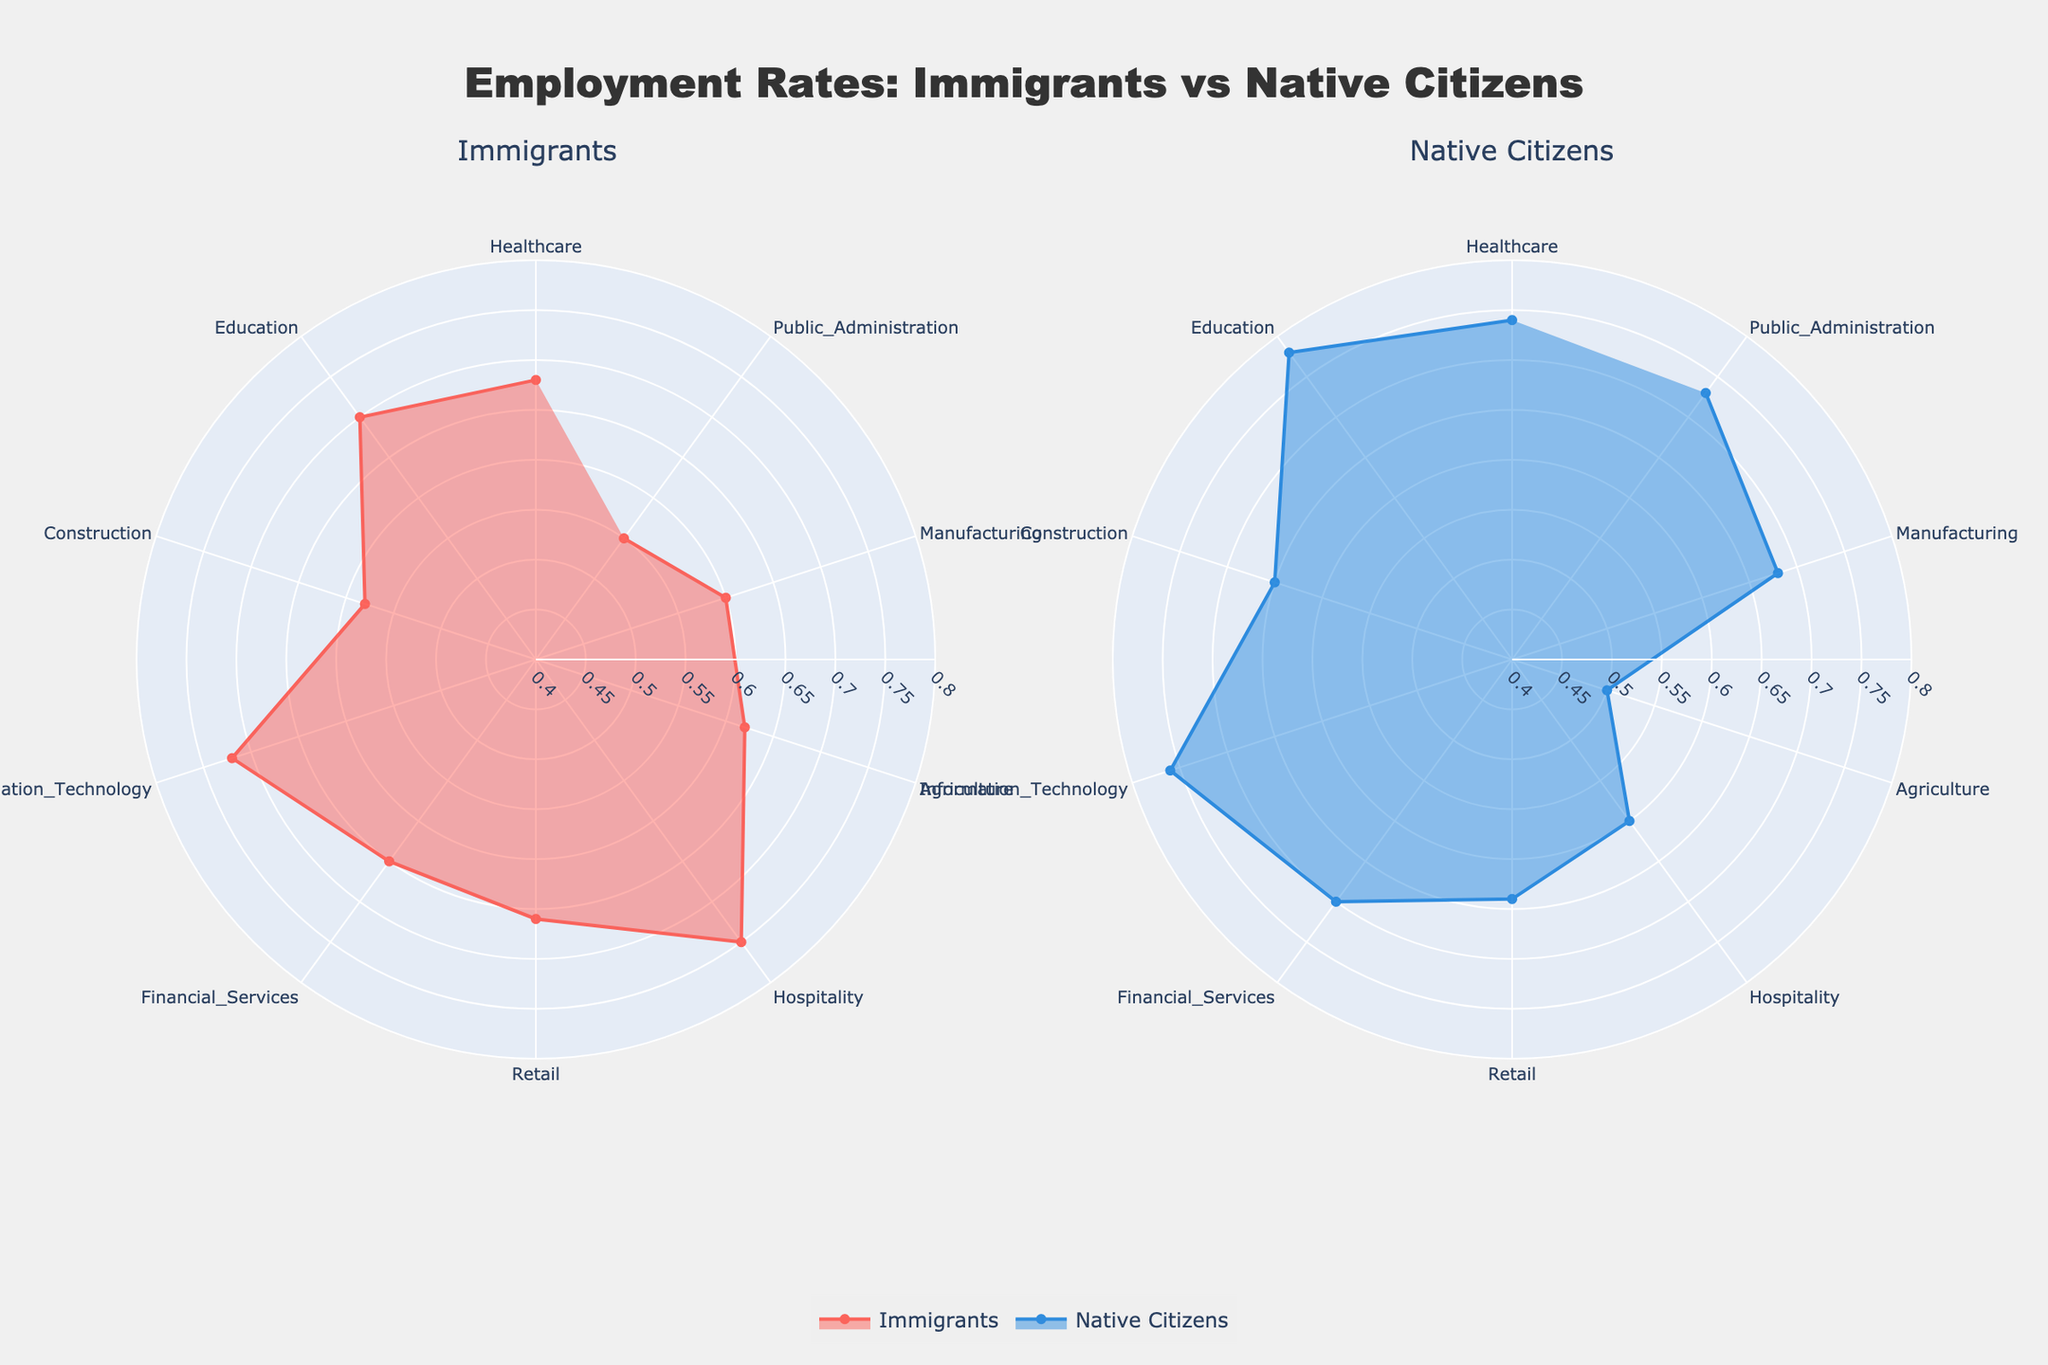What is the title of the figure? The title is displayed at the top center of the figure. It reads "Employment Rates: Immigrants vs Native Citizens" based on the code provided.
Answer: Employment Rates: Immigrants vs Native Citizens Which sector has the highest employment rate for immigrants? To find the highest employment rate, compare the values for immigrants in each sector. Hospitality has the highest rate with 0.75.
Answer: Hospitality In which sector is the employment rate for native citizens the highest? Review the employment rates for native citizens across sectors. Education has the highest rate of 0.78.
Answer: Education How does the employment rate for immigrants in the Information Technology sector compare to that for native citizens? The rate for immigrants in Information Technology is 0.72, while it is 0.76 for native citizens. Therefore, native citizens have a higher rate.
Answer: Native citizens have a higher rate Which sector shows the greatest difference in employment rates between immigrants and native citizens, and what is the difference? Calculate the differences in employment rates for each sector. Public Administration shows the greatest difference with native citizens at 0.73 and immigrants at 0.55, a difference of 0.18.
Answer: Public Administration, 0.18 What is the average employment rate for immigrants across all sectors? Sum the employment rates for immigrants and divide by the number of sectors: (0.68 + 0.70 + 0.58 + 0.72 + 0.65 + 0.66 + 0.75 + 0.62 + 0.60 + 0.55) / 10 = 0.651.
Answer: 0.651 Which sector has a higher employment rate for immigrants than for native citizens? Compare each sector's rates to see which ones have a higher rate for immigrants. Retail and Hospitality have higher rates for immigrants at 0.66 and 0.75 compared to 0.64 and 0.60 for native citizens, respectively.
Answer: Retail and Hospitality By how much does the employment rate for immigrants in Healthcare differ from that in Construction? Subtract the rate in Construction from the rate in Healthcare: 0.68 - 0.58 = 0.10.
Answer: 0.10 In which sector is the difference in employment rates between immigrants and native citizens the smallest, and what is that difference? Calculate the differences for each sector and find the smallest: Information Technology has the smallest difference, with 0.72 for immigrants and 0.76 for native citizens, a difference of 0.04.
Answer: Information Technology, 0.04 For the Agriculture sector, how does the employment rate for immigrants compare to the overall average employment rate for native citizens? First, calculate the overall average for native citizens: (0.74 + 0.78 + 0.65 + 0.76 + 0.70 + 0.64 + 0.60 + 0.50 + 0.68 + 0.73) / 10 = 0.678. Then compare it to the Agriculture rate for immigrants, which is 0.62. 0.62 is less than 0.678.
Answer: It is lower 